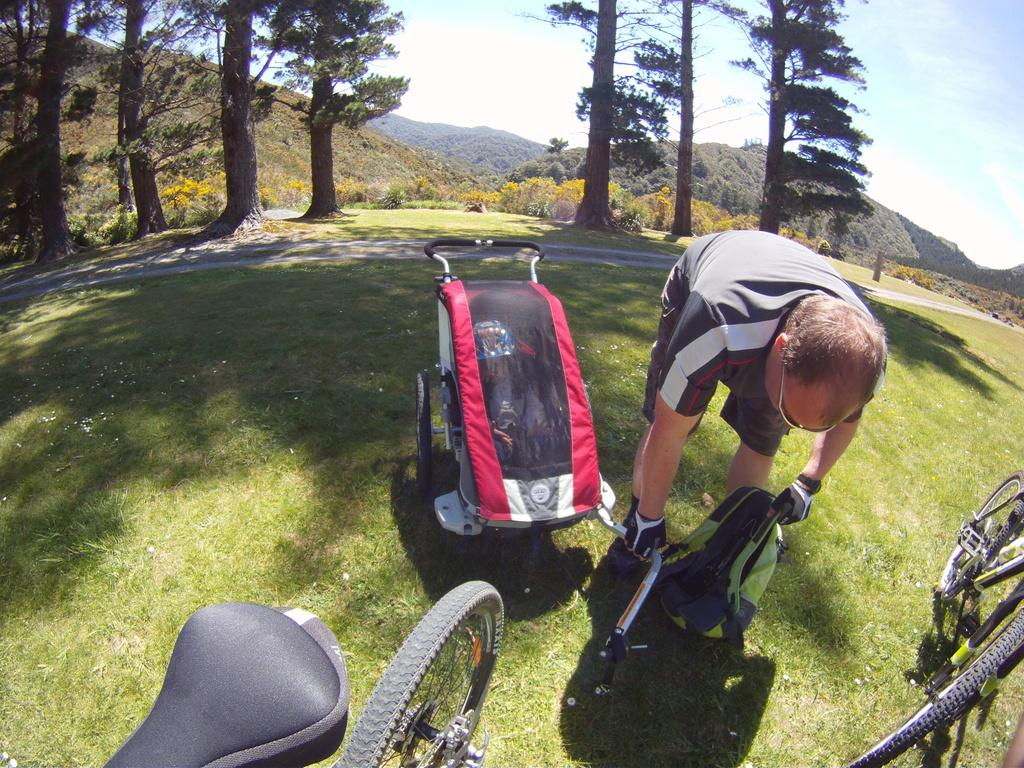Who is present in the image? There is a man in the image. What is the man holding in his hand? The man is holding a bag in his hand. What can be seen besides the man in the image? There are bicycles and trees visible in the image. What type of vehicle is present in the image? There is a baby trolley in the image. What direction is the man facing in the image? The provided facts do not mention the direction the man is facing, so it cannot be determined from the image. 